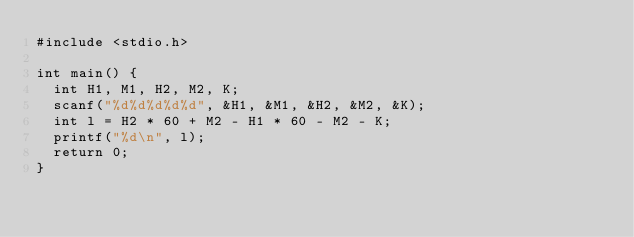Convert code to text. <code><loc_0><loc_0><loc_500><loc_500><_C_>#include <stdio.h>

int main() {
  int H1, M1, H2, M2, K;
  scanf("%d%d%d%d%d", &H1, &M1, &H2, &M2, &K);
  int l = H2 * 60 + M2 - H1 * 60 - M2 - K;
  printf("%d\n", l);
  return 0;
}</code> 